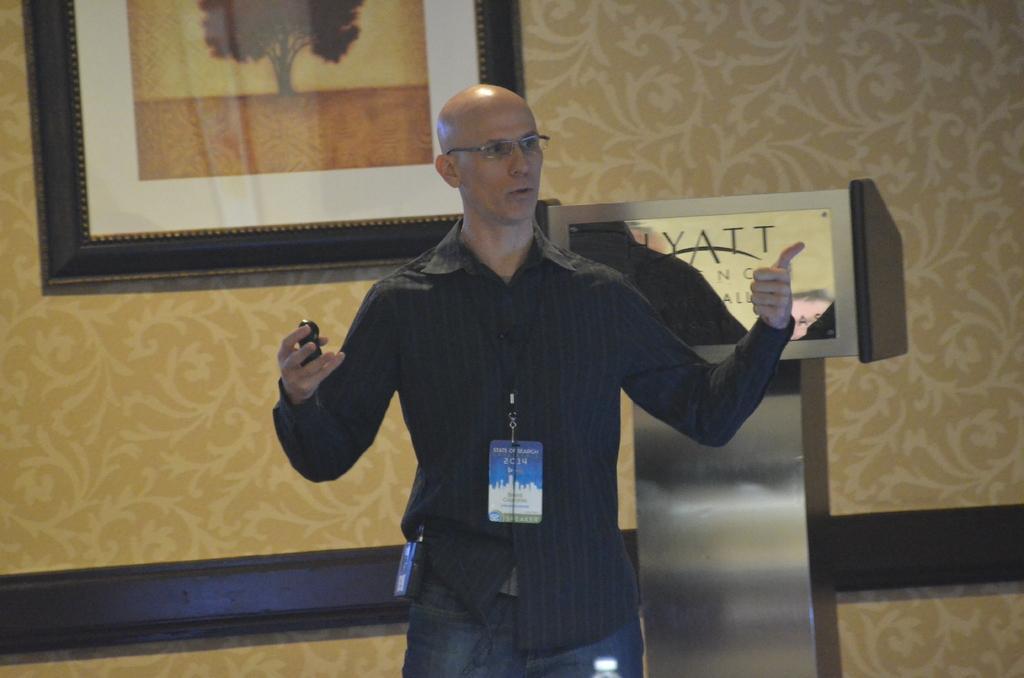Please provide a concise description of this image. In this image, we can see a person holding some object. We can see a podium with a board and some text. We can also see the design wall with a photo frame. 